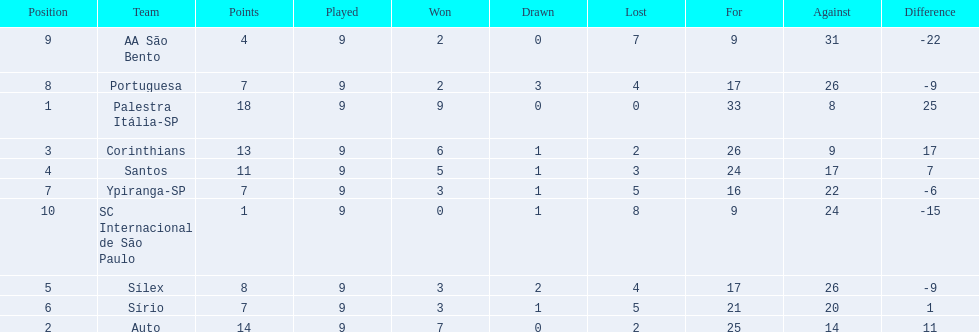Which teams were playing brazilian football in 1926? Palestra Itália-SP, Auto, Corinthians, Santos, Sílex, Sírio, Ypiranga-SP, Portuguesa, AA São Bento, SC Internacional de São Paulo. Of those teams, which one scored 13 points? Corinthians. 